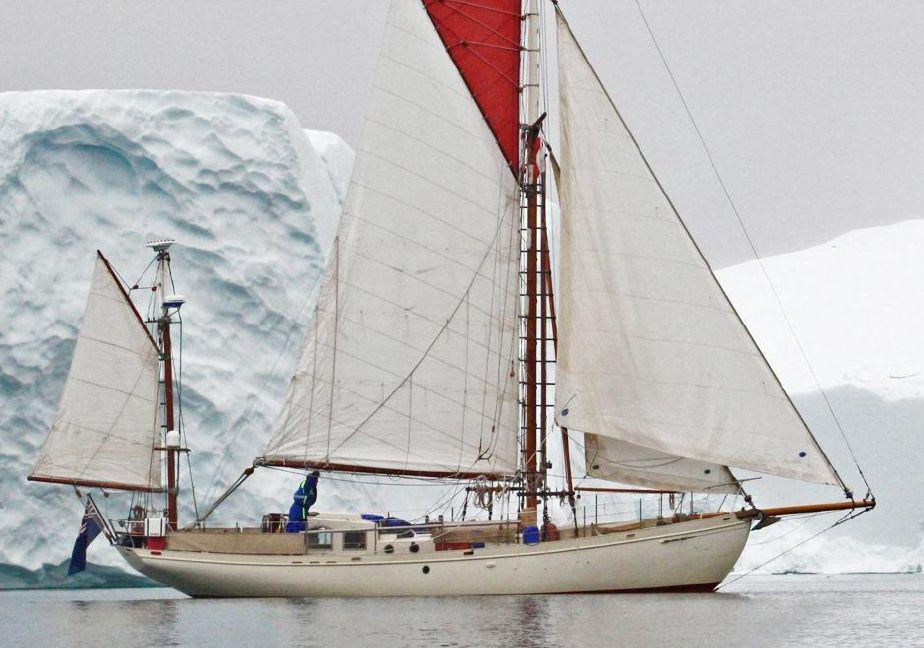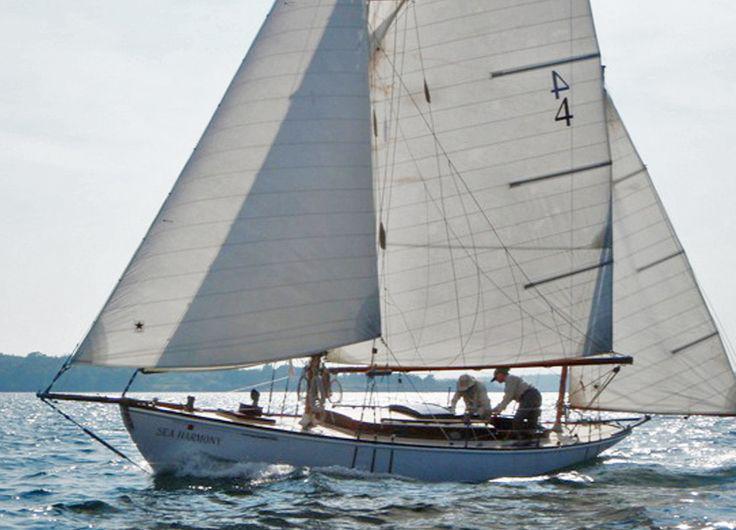The first image is the image on the left, the second image is the image on the right. Analyze the images presented: Is the assertion "One of the boats only has two sails [unfurled]." valid? Answer yes or no. No. The first image is the image on the left, the second image is the image on the right. Examine the images to the left and right. Is the description "The sail boat in the right image has three sails engaged." accurate? Answer yes or no. Yes. 